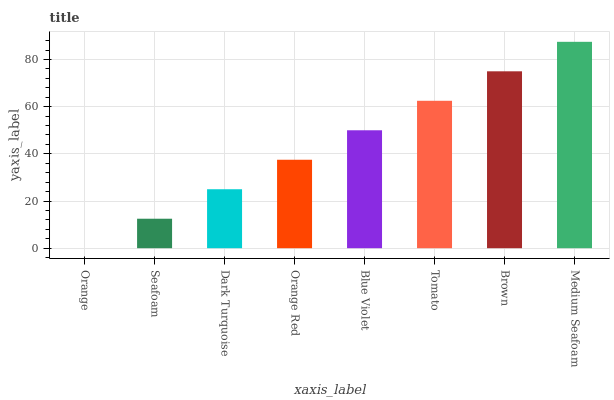Is Orange the minimum?
Answer yes or no. Yes. Is Medium Seafoam the maximum?
Answer yes or no. Yes. Is Seafoam the minimum?
Answer yes or no. No. Is Seafoam the maximum?
Answer yes or no. No. Is Seafoam greater than Orange?
Answer yes or no. Yes. Is Orange less than Seafoam?
Answer yes or no. Yes. Is Orange greater than Seafoam?
Answer yes or no. No. Is Seafoam less than Orange?
Answer yes or no. No. Is Blue Violet the high median?
Answer yes or no. Yes. Is Orange Red the low median?
Answer yes or no. Yes. Is Tomato the high median?
Answer yes or no. No. Is Brown the low median?
Answer yes or no. No. 